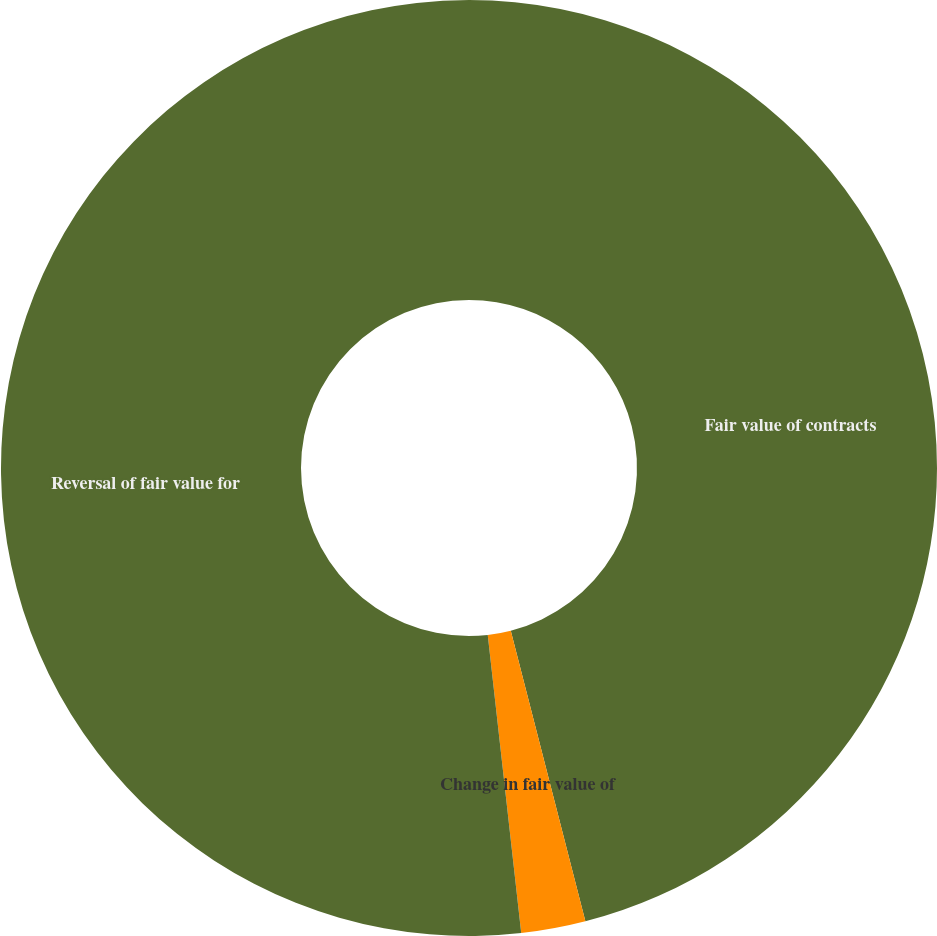Convert chart to OTSL. <chart><loc_0><loc_0><loc_500><loc_500><pie_chart><fcel>Fair value of contracts<fcel>Change in fair value of<fcel>Reversal of fair value for<nl><fcel>46.0%<fcel>2.22%<fcel>51.78%<nl></chart> 